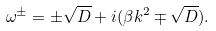<formula> <loc_0><loc_0><loc_500><loc_500>\omega ^ { \pm } = \pm \sqrt { D } + i ( \beta k ^ { 2 } \mp \sqrt { D } ) .</formula> 